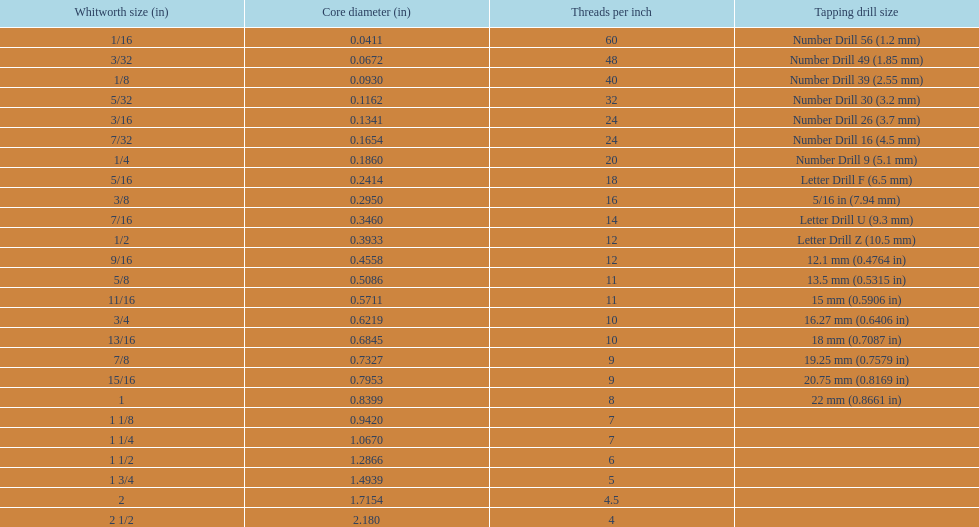What is the primary diameter of the first 1/8 whitworth dimension (in)? 0.0930. 